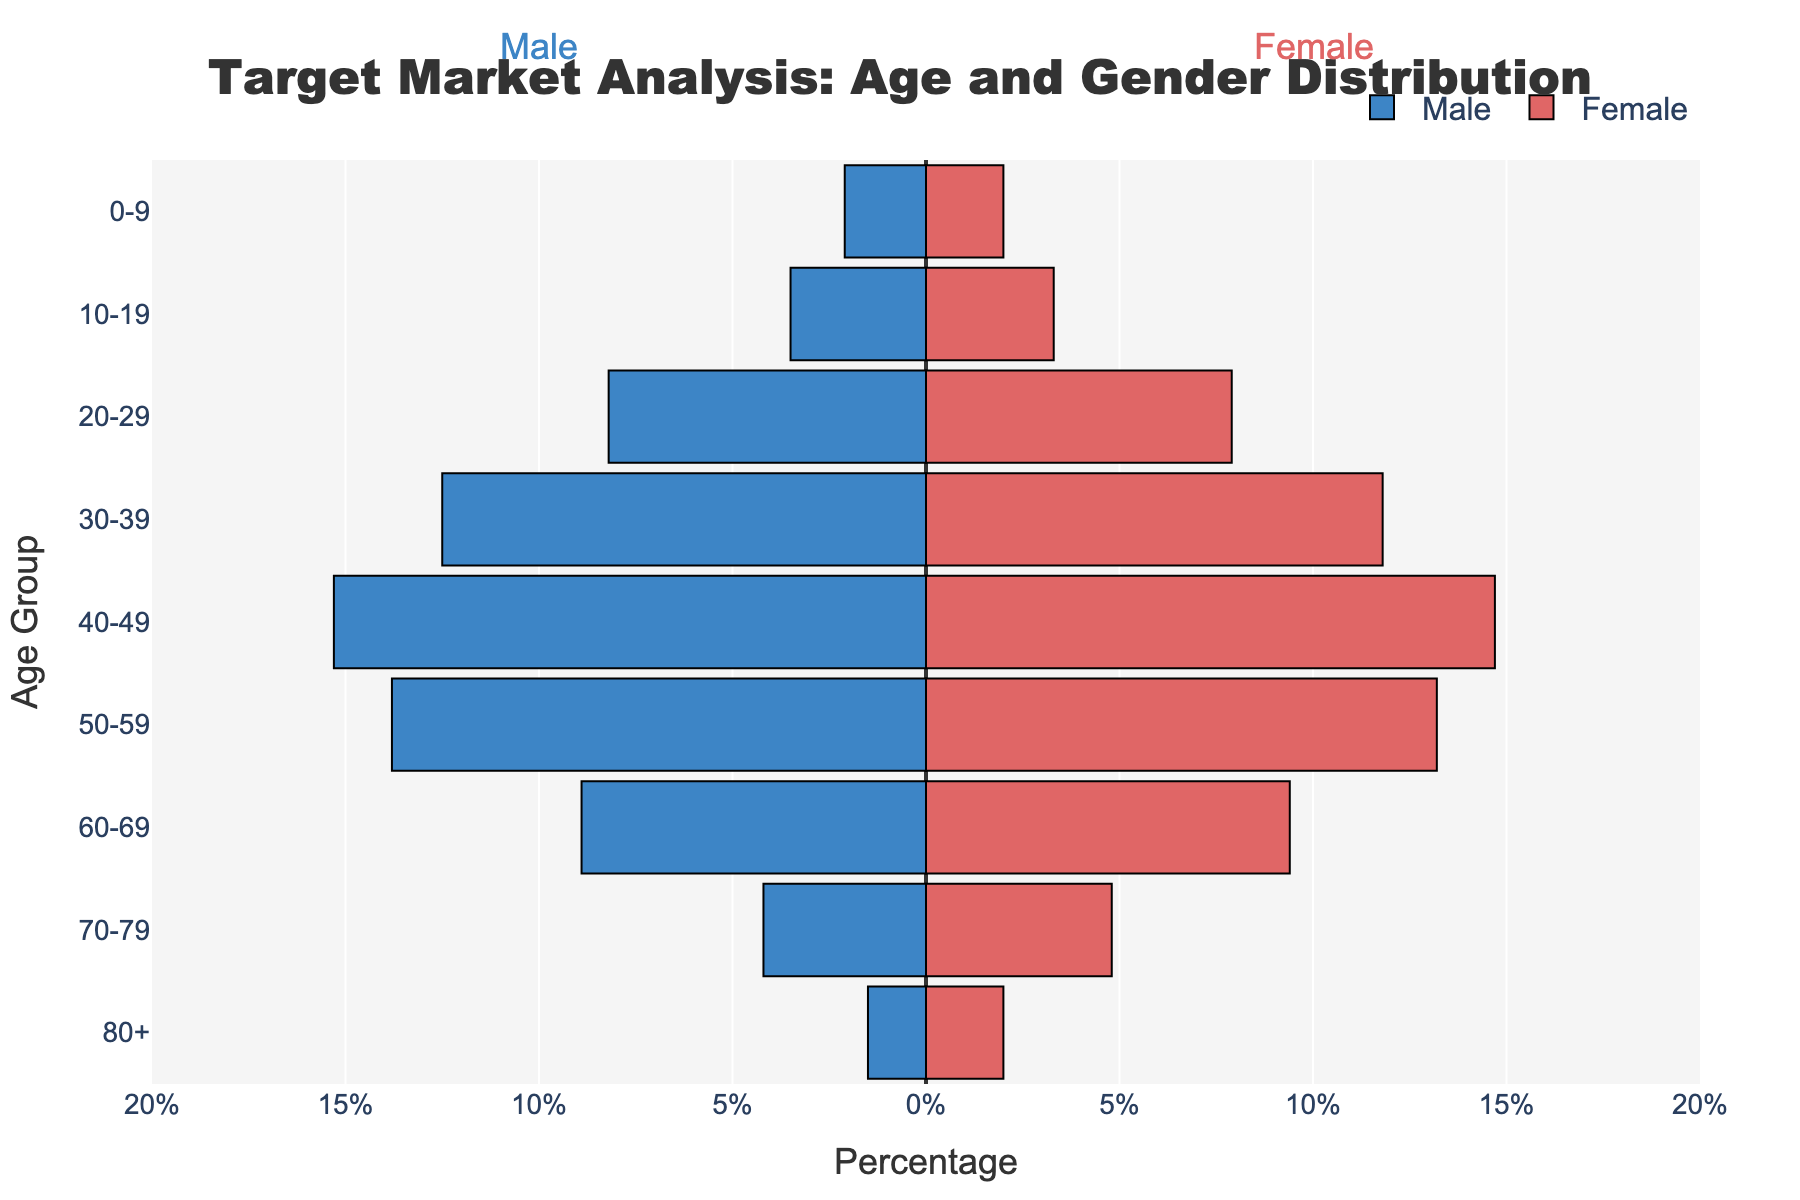What is the title of the population pyramid? The title is located at the top of the figure. It reads "Target Market Analysis: Age and Gender Distribution," which gives a clear understanding of the demographic focus.
Answer: Target Market Analysis: Age and Gender Distribution What age group has the highest percentage of males? To find this, look at the length of the bars representing males (blue) and identify the longest one. The age group 40-49 has the longest bar for males.
Answer: 40-49 Which gender has a higher percentage in the 60-69 age group? Compare the lengths of the bars for males (blue) and females (red) in the 60-69 age group. The female bar is slightly longer, indicating a higher percentage of females in this age group.
Answer: Female What's the combined percentage of males and females in the 30-39 age group? To get the combined percentage, add the male and female percentages for the 30-39 age group. Male percentage is 12.5, and female percentage is 11.8. So, 12.5 + 11.8 = 24.3%.
Answer: 24.3% Which age group has the least gender difference in percentage? Calculate the absolute difference between the male and female percentages for each age group and find the smallest difference. The age group 0-9 has males at 2.1% and females at 2.0%, making the difference 0.1, which is the smallest.
Answer: 0-9 How does the population of males in the 50-59 age group compare to the population of females in the same group? Compare the length of the blue (males) and red (females) bars. Males are at 13.8% while females are at 13.2%. Males have a slightly higher percentage in this age group.
Answer: Males have a higher percentage What age group shows the greatest population decline from the previous age group for males? Look for the biggest drop between adjacent bars for males (blue). From 50-59 (13.8%) to 60-69 (8.9%) there is a drop of 4.9%, which is the largest.
Answer: 60-69 Which age group has a higher proportion of females compared to males? Compare the lengths of male (blue) and female (red) bars in each age group. In the age group 70-79 and 80+, the female bar is significantly longer than the male bar. The age group 80+ shows the highest proportion of females compared to males.
Answer: 80+ What is the percentage difference between males and females in the 40-49 age group? Calculate the difference between male and female percentages for 40-49. Males are at 15.3%, and females are at 14.7%. The difference is 15.3 - 14.7 = 0.6%.
Answer: 0.6% In terms of marketing focus, which age group should be prioritized for balanced gender representation? Identify the age groups where male and female percentages are close, indicating balanced representation. The age group 0-9 should be prioritized as it has the closest percentages (2.1% males and 2.0% females).
Answer: 0-9 